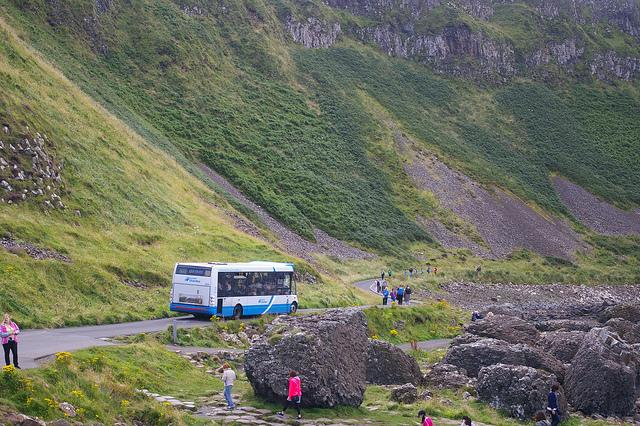What act of nature could potentially physically impede progress on the road?

Choices:
A) pandemic
B) flood
C) landslide
D) lightning landslide 